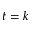<formula> <loc_0><loc_0><loc_500><loc_500>t = k</formula> 